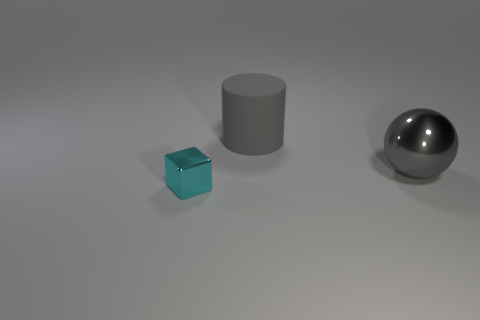There is another thing that is the same size as the gray metal object; what color is it? The other object that matches the size of the gray metal cylinder appears to be a blue cube. 